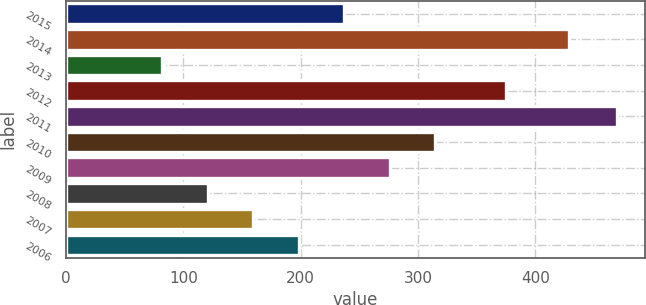Convert chart. <chart><loc_0><loc_0><loc_500><loc_500><bar_chart><fcel>2015<fcel>2014<fcel>2013<fcel>2012<fcel>2011<fcel>2010<fcel>2009<fcel>2008<fcel>2007<fcel>2006<nl><fcel>237.2<fcel>429<fcel>82<fcel>375<fcel>470<fcel>314.8<fcel>276<fcel>120.8<fcel>159.6<fcel>198.4<nl></chart> 